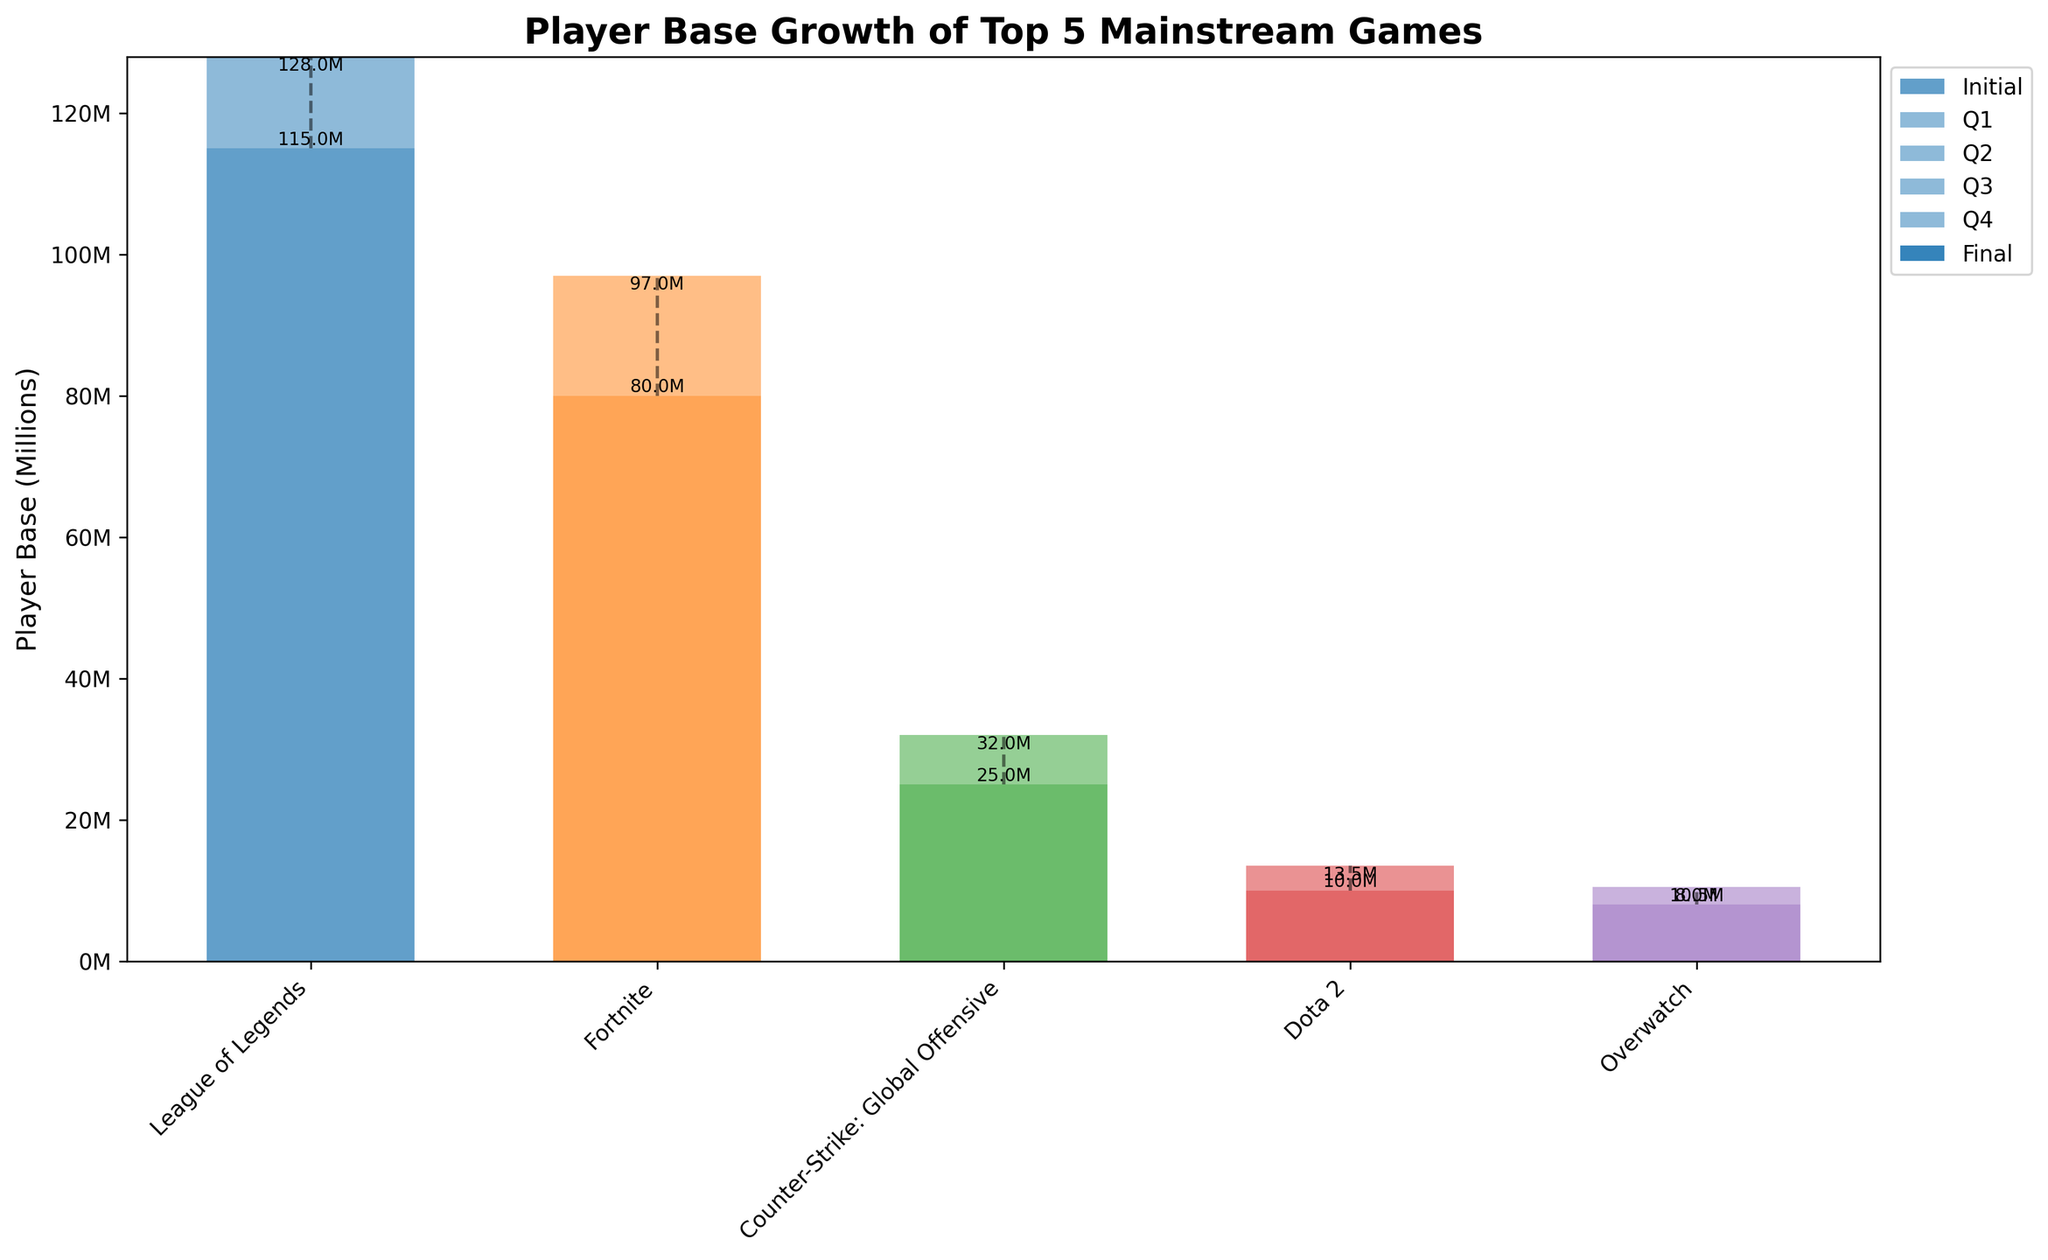What is the title of the chart? The title is typically displayed at the top of the chart. In this case, the specified title of the chart is "Player Base Growth of Top 5 Mainstream Games".
Answer: Player Base Growth of Top 5 Mainstream Games Which game had the largest initial player base? Look at the initial bars in the chart and verify the corresponding values. The "League of Legends" appears to start with the largest initial player base of 115 million.
Answer: League of Legends Which game had the smallest final player base? Observe the final bars in the chart to identify the smallest value. "Overwatch" has the smallest final player base of 10.5 million.
Answer: Overwatch How much did Fortnite's player base grow in the second quarter (Q2)? Refer to the Q2 bar segment for Fortnite. It shows an increase of 4.5 million (corresponding to the Q2 increase value).
Answer: 4.5 million What is the total growth in player base for Dota 2 throughout the year? To find the total growth, add up the increases for each quarter: 0.5 million (Q1) + 0.75 million (Q2) + 1 million (Q3) + 1.25 million (Q4) = 3.5 million.
Answer: 3.5 million Compare the final player bases of League of Legends and Fortnite. Which one is higher? The final bar heights for these games indicate their final values. League of Legends has a final player base of 128 million, and Fortnite has 97 million. League of Legends is higher.
Answer: League of Legends Which quarter contributed the most to the player base growth of Counter-Strike: Global Offensive? Examine the segment heights in each quarter for Counter-Strike: Global Offensive. The Q4 segment is the largest, with an increase of 2.5 million.
Answer: Q4 What is the combined player base of all five games at the end of the year? Sum the final player base values: 128 million (League of Legends) + 97 million (Fortnite) + 32 million (Counter-Strike: Global Offensive) + 13.5 million (Dota 2) + 10.5 million (Overwatch) = 281 million.
Answer: 281 million Which two games had the closest initial player bases? Compare the initial bar heights for all games. Fortnite and Counter-Strike: Global Offensive have initial values of 80 million and 25 million, respectively, which do not pair closely. The closest pair is Dota 2 (10 million) and Overwatch (8 million).
Answer: Dota 2 and Overwatch How does the growth pattern of League of Legends compare to Overwatch from Q1 to Q4? Analyze the incremental increases across quarters for both games. League of Legends shows steady growth with increments of 2.5 million (Q1), 3 million (Q2), 3.5 million (Q3), and 4 million (Q4). Overwatch also shows steady but smaller increments with 0.25 million (Q1), 0.5 million (Q2), 0.75 million (Q3), and 1 million (Q4).
Answer: Steady, but League of Legends has larger increments 